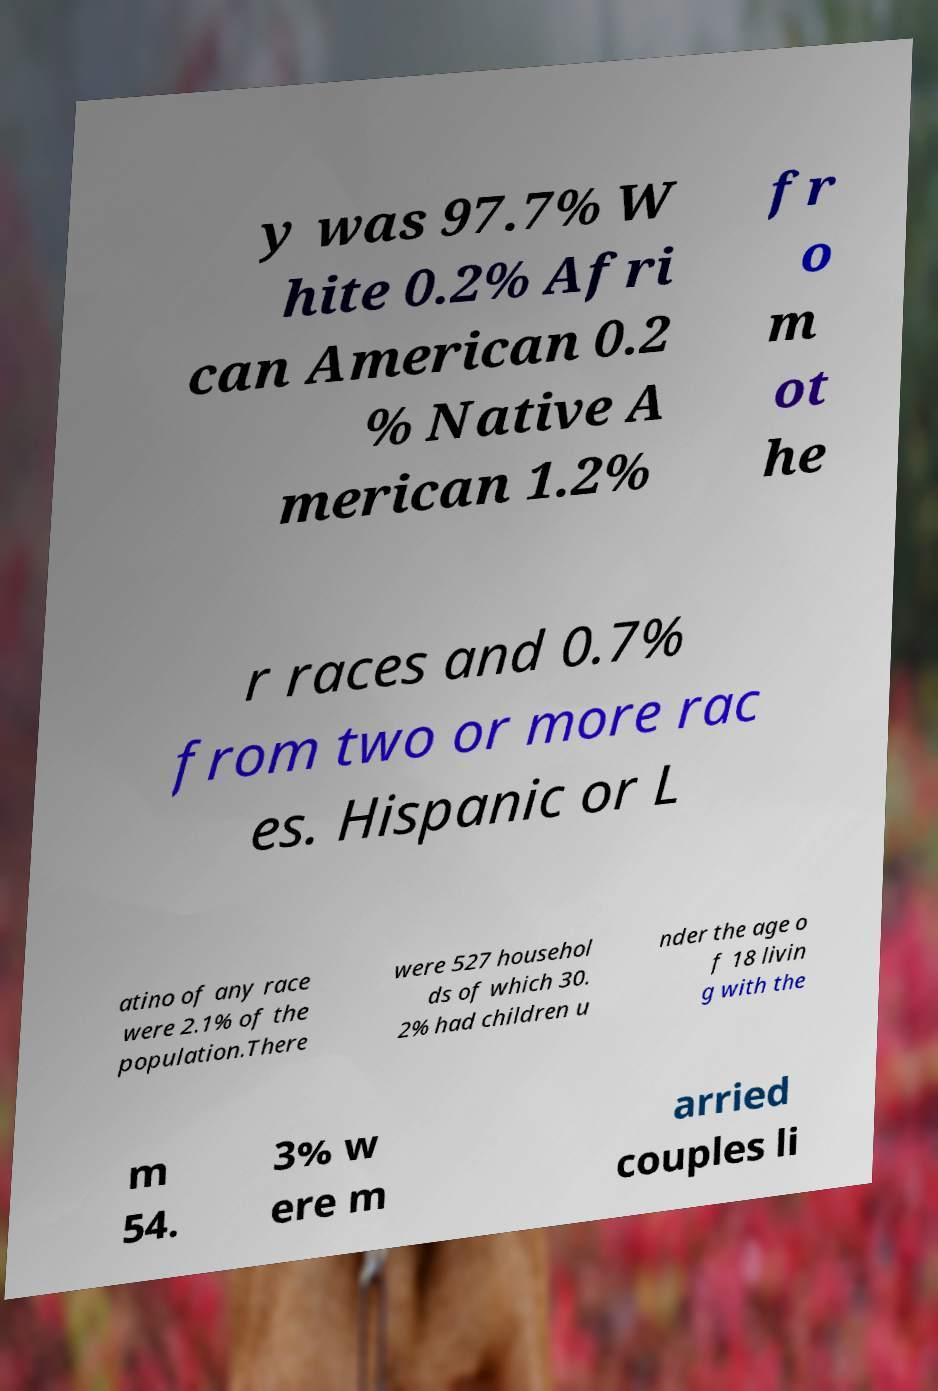Please identify and transcribe the text found in this image. y was 97.7% W hite 0.2% Afri can American 0.2 % Native A merican 1.2% fr o m ot he r races and 0.7% from two or more rac es. Hispanic or L atino of any race were 2.1% of the population.There were 527 househol ds of which 30. 2% had children u nder the age o f 18 livin g with the m 54. 3% w ere m arried couples li 